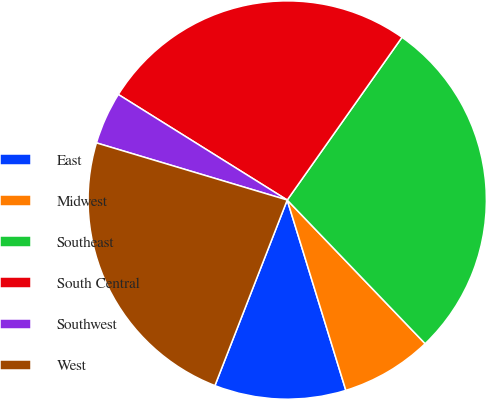<chart> <loc_0><loc_0><loc_500><loc_500><pie_chart><fcel>East<fcel>Midwest<fcel>Southeast<fcel>South Central<fcel>Southwest<fcel>West<nl><fcel>10.67%<fcel>7.42%<fcel>28.05%<fcel>25.89%<fcel>4.26%<fcel>23.72%<nl></chart> 